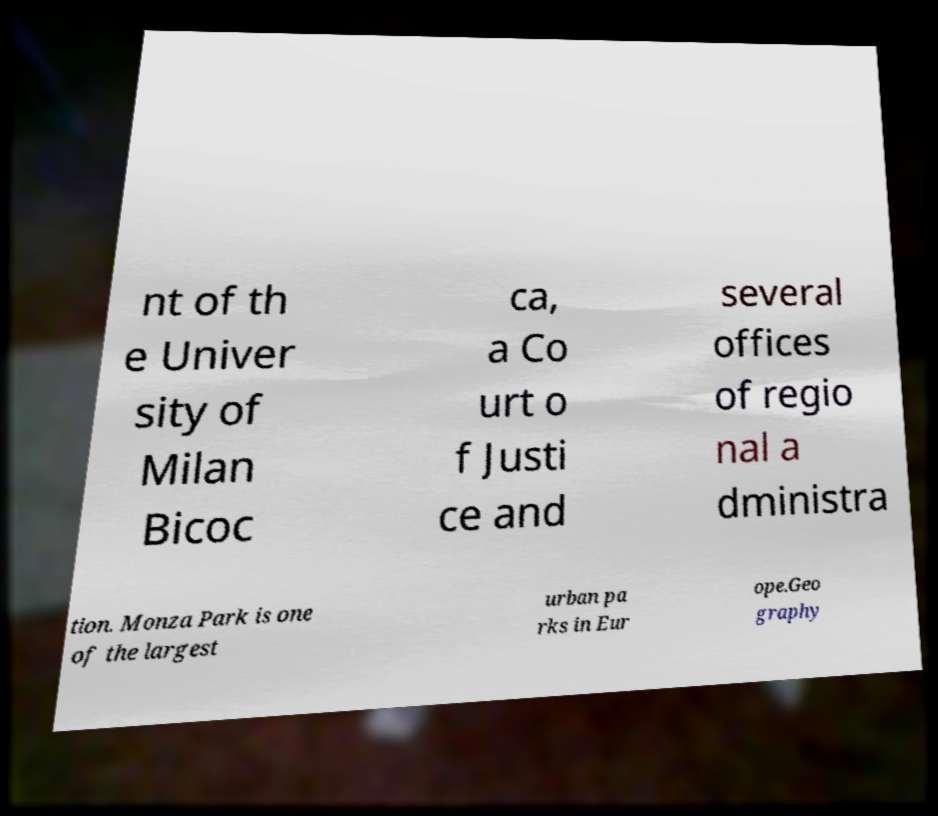Can you read and provide the text displayed in the image?This photo seems to have some interesting text. Can you extract and type it out for me? nt of th e Univer sity of Milan Bicoc ca, a Co urt o f Justi ce and several offices of regio nal a dministra tion. Monza Park is one of the largest urban pa rks in Eur ope.Geo graphy 